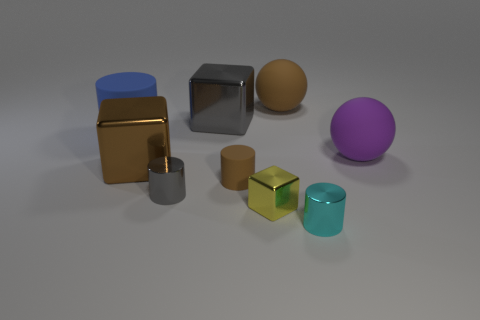There is a block that is the same color as the small rubber cylinder; what material is it?
Offer a very short reply. Metal. How many things are shiny things that are to the left of the tiny brown matte cylinder or brown blocks?
Your answer should be very brief. 3. There is a blue rubber cylinder that is behind the cyan metallic cylinder; does it have the same size as the gray metallic cylinder?
Your answer should be very brief. No. Is the number of cyan cylinders on the right side of the small cyan thing less than the number of blue spheres?
Offer a terse response. No. What material is the cylinder that is the same size as the purple matte thing?
Ensure brevity in your answer.  Rubber. How many large things are gray things or blue matte cylinders?
Ensure brevity in your answer.  2. How many objects are tiny cylinders that are to the left of the cyan cylinder or shiny cylinders that are on the left side of the cyan object?
Your response must be concise. 2. Is the number of big yellow cylinders less than the number of tiny gray metal objects?
Keep it short and to the point. Yes. The yellow metallic thing that is the same size as the cyan metallic object is what shape?
Your answer should be compact. Cube. What number of other objects are there of the same color as the big rubber cylinder?
Keep it short and to the point. 0. 